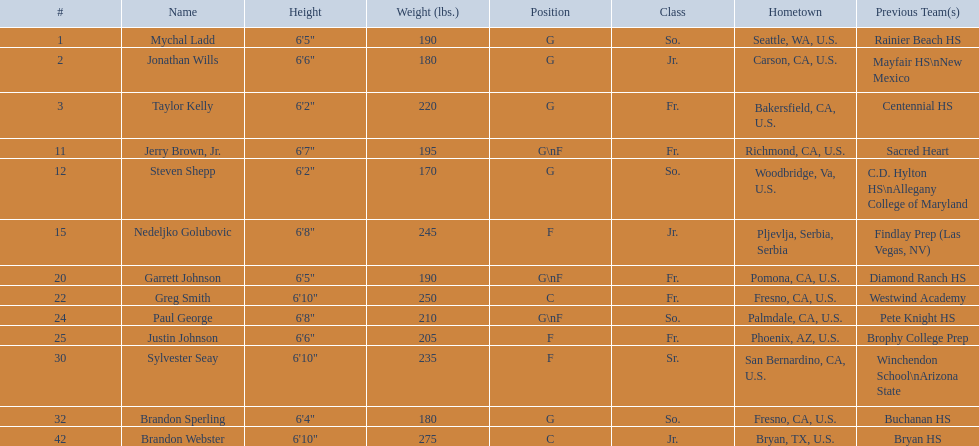Which positions are so.? G, G, G\nF, G. Which weights are g 190, 170, 180. What height is under 6 3' 6'2". What is the name Steven Shepp. 